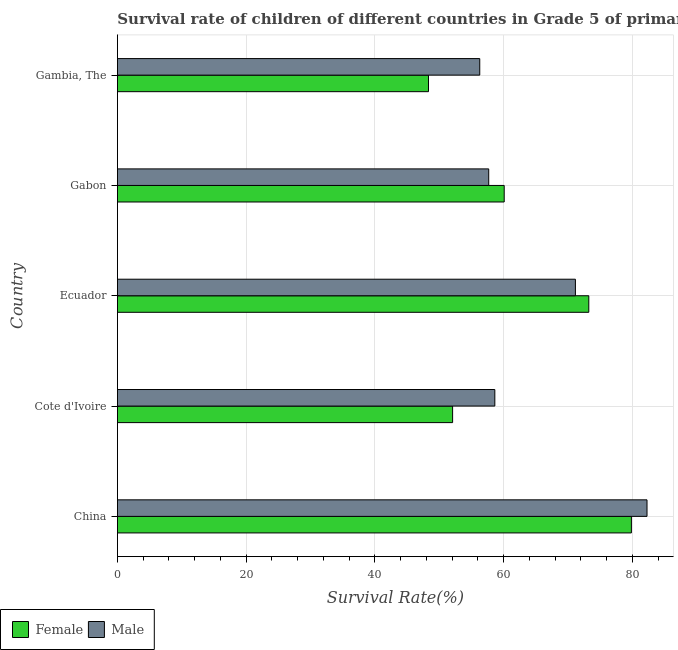How many different coloured bars are there?
Give a very brief answer. 2. How many bars are there on the 2nd tick from the bottom?
Provide a succinct answer. 2. What is the label of the 2nd group of bars from the top?
Ensure brevity in your answer.  Gabon. What is the survival rate of female students in primary education in Ecuador?
Your answer should be compact. 73.22. Across all countries, what is the maximum survival rate of male students in primary education?
Provide a succinct answer. 82.26. Across all countries, what is the minimum survival rate of female students in primary education?
Your answer should be very brief. 48.32. In which country was the survival rate of male students in primary education minimum?
Give a very brief answer. Gambia, The. What is the total survival rate of male students in primary education in the graph?
Your answer should be very brief. 325.99. What is the difference between the survival rate of male students in primary education in Cote d'Ivoire and that in Gabon?
Offer a very short reply. 0.95. What is the difference between the survival rate of female students in primary education in Ecuador and the survival rate of male students in primary education in Gabon?
Your answer should be very brief. 15.55. What is the average survival rate of male students in primary education per country?
Keep it short and to the point. 65.2. What is the difference between the survival rate of female students in primary education and survival rate of male students in primary education in China?
Offer a very short reply. -2.43. In how many countries, is the survival rate of male students in primary education greater than 20 %?
Give a very brief answer. 5. What is the ratio of the survival rate of male students in primary education in Cote d'Ivoire to that in Gambia, The?
Keep it short and to the point. 1.04. Is the difference between the survival rate of female students in primary education in Cote d'Ivoire and Gambia, The greater than the difference between the survival rate of male students in primary education in Cote d'Ivoire and Gambia, The?
Keep it short and to the point. Yes. What is the difference between the highest and the second highest survival rate of male students in primary education?
Your answer should be compact. 11.12. What is the difference between the highest and the lowest survival rate of male students in primary education?
Make the answer very short. 25.98. Is the sum of the survival rate of male students in primary education in China and Cote d'Ivoire greater than the maximum survival rate of female students in primary education across all countries?
Provide a succinct answer. Yes. What does the 2nd bar from the top in China represents?
Give a very brief answer. Female. What does the 2nd bar from the bottom in Gabon represents?
Keep it short and to the point. Male. How many bars are there?
Provide a short and direct response. 10. Are all the bars in the graph horizontal?
Offer a very short reply. Yes. What is the difference between two consecutive major ticks on the X-axis?
Your response must be concise. 20. Are the values on the major ticks of X-axis written in scientific E-notation?
Keep it short and to the point. No. Does the graph contain any zero values?
Your answer should be very brief. No. How many legend labels are there?
Your answer should be compact. 2. How are the legend labels stacked?
Your answer should be compact. Horizontal. What is the title of the graph?
Your answer should be compact. Survival rate of children of different countries in Grade 5 of primary education. Does "Canada" appear as one of the legend labels in the graph?
Ensure brevity in your answer.  No. What is the label or title of the X-axis?
Offer a terse response. Survival Rate(%). What is the Survival Rate(%) of Female in China?
Ensure brevity in your answer.  79.84. What is the Survival Rate(%) of Male in China?
Your answer should be very brief. 82.26. What is the Survival Rate(%) in Female in Cote d'Ivoire?
Offer a very short reply. 52.07. What is the Survival Rate(%) in Male in Cote d'Ivoire?
Make the answer very short. 58.63. What is the Survival Rate(%) of Female in Ecuador?
Your answer should be very brief. 73.22. What is the Survival Rate(%) of Male in Ecuador?
Ensure brevity in your answer.  71.14. What is the Survival Rate(%) of Female in Gabon?
Offer a terse response. 60.08. What is the Survival Rate(%) in Male in Gabon?
Your answer should be very brief. 57.68. What is the Survival Rate(%) of Female in Gambia, The?
Keep it short and to the point. 48.32. What is the Survival Rate(%) of Male in Gambia, The?
Offer a terse response. 56.28. Across all countries, what is the maximum Survival Rate(%) in Female?
Your answer should be very brief. 79.84. Across all countries, what is the maximum Survival Rate(%) in Male?
Offer a very short reply. 82.26. Across all countries, what is the minimum Survival Rate(%) of Female?
Provide a succinct answer. 48.32. Across all countries, what is the minimum Survival Rate(%) in Male?
Keep it short and to the point. 56.28. What is the total Survival Rate(%) in Female in the graph?
Your answer should be very brief. 313.53. What is the total Survival Rate(%) of Male in the graph?
Your response must be concise. 325.99. What is the difference between the Survival Rate(%) of Female in China and that in Cote d'Ivoire?
Provide a succinct answer. 27.77. What is the difference between the Survival Rate(%) of Male in China and that in Cote d'Ivoire?
Your response must be concise. 23.64. What is the difference between the Survival Rate(%) in Female in China and that in Ecuador?
Make the answer very short. 6.61. What is the difference between the Survival Rate(%) in Male in China and that in Ecuador?
Ensure brevity in your answer.  11.12. What is the difference between the Survival Rate(%) of Female in China and that in Gabon?
Provide a short and direct response. 19.76. What is the difference between the Survival Rate(%) of Male in China and that in Gabon?
Provide a short and direct response. 24.59. What is the difference between the Survival Rate(%) of Female in China and that in Gambia, The?
Ensure brevity in your answer.  31.52. What is the difference between the Survival Rate(%) of Male in China and that in Gambia, The?
Ensure brevity in your answer.  25.98. What is the difference between the Survival Rate(%) in Female in Cote d'Ivoire and that in Ecuador?
Give a very brief answer. -21.15. What is the difference between the Survival Rate(%) in Male in Cote d'Ivoire and that in Ecuador?
Make the answer very short. -12.52. What is the difference between the Survival Rate(%) in Female in Cote d'Ivoire and that in Gabon?
Offer a very short reply. -8.01. What is the difference between the Survival Rate(%) of Male in Cote d'Ivoire and that in Gabon?
Give a very brief answer. 0.95. What is the difference between the Survival Rate(%) in Female in Cote d'Ivoire and that in Gambia, The?
Offer a terse response. 3.75. What is the difference between the Survival Rate(%) in Male in Cote d'Ivoire and that in Gambia, The?
Ensure brevity in your answer.  2.34. What is the difference between the Survival Rate(%) of Female in Ecuador and that in Gabon?
Provide a short and direct response. 13.14. What is the difference between the Survival Rate(%) in Male in Ecuador and that in Gabon?
Make the answer very short. 13.47. What is the difference between the Survival Rate(%) of Female in Ecuador and that in Gambia, The?
Provide a short and direct response. 24.9. What is the difference between the Survival Rate(%) in Male in Ecuador and that in Gambia, The?
Your response must be concise. 14.86. What is the difference between the Survival Rate(%) in Female in Gabon and that in Gambia, The?
Your response must be concise. 11.76. What is the difference between the Survival Rate(%) of Male in Gabon and that in Gambia, The?
Give a very brief answer. 1.39. What is the difference between the Survival Rate(%) of Female in China and the Survival Rate(%) of Male in Cote d'Ivoire?
Your answer should be very brief. 21.21. What is the difference between the Survival Rate(%) of Female in China and the Survival Rate(%) of Male in Ecuador?
Offer a terse response. 8.7. What is the difference between the Survival Rate(%) in Female in China and the Survival Rate(%) in Male in Gabon?
Your answer should be very brief. 22.16. What is the difference between the Survival Rate(%) in Female in China and the Survival Rate(%) in Male in Gambia, The?
Keep it short and to the point. 23.55. What is the difference between the Survival Rate(%) of Female in Cote d'Ivoire and the Survival Rate(%) of Male in Ecuador?
Your answer should be very brief. -19.07. What is the difference between the Survival Rate(%) of Female in Cote d'Ivoire and the Survival Rate(%) of Male in Gabon?
Your answer should be very brief. -5.61. What is the difference between the Survival Rate(%) in Female in Cote d'Ivoire and the Survival Rate(%) in Male in Gambia, The?
Your response must be concise. -4.21. What is the difference between the Survival Rate(%) of Female in Ecuador and the Survival Rate(%) of Male in Gabon?
Give a very brief answer. 15.55. What is the difference between the Survival Rate(%) in Female in Ecuador and the Survival Rate(%) in Male in Gambia, The?
Your answer should be compact. 16.94. What is the difference between the Survival Rate(%) in Female in Gabon and the Survival Rate(%) in Male in Gambia, The?
Provide a succinct answer. 3.8. What is the average Survival Rate(%) of Female per country?
Provide a short and direct response. 62.71. What is the average Survival Rate(%) of Male per country?
Give a very brief answer. 65.2. What is the difference between the Survival Rate(%) of Female and Survival Rate(%) of Male in China?
Provide a short and direct response. -2.43. What is the difference between the Survival Rate(%) in Female and Survival Rate(%) in Male in Cote d'Ivoire?
Provide a succinct answer. -6.56. What is the difference between the Survival Rate(%) in Female and Survival Rate(%) in Male in Ecuador?
Provide a short and direct response. 2.08. What is the difference between the Survival Rate(%) in Female and Survival Rate(%) in Male in Gabon?
Give a very brief answer. 2.4. What is the difference between the Survival Rate(%) in Female and Survival Rate(%) in Male in Gambia, The?
Your response must be concise. -7.96. What is the ratio of the Survival Rate(%) in Female in China to that in Cote d'Ivoire?
Give a very brief answer. 1.53. What is the ratio of the Survival Rate(%) in Male in China to that in Cote d'Ivoire?
Your answer should be very brief. 1.4. What is the ratio of the Survival Rate(%) in Female in China to that in Ecuador?
Make the answer very short. 1.09. What is the ratio of the Survival Rate(%) of Male in China to that in Ecuador?
Your answer should be very brief. 1.16. What is the ratio of the Survival Rate(%) of Female in China to that in Gabon?
Offer a very short reply. 1.33. What is the ratio of the Survival Rate(%) of Male in China to that in Gabon?
Make the answer very short. 1.43. What is the ratio of the Survival Rate(%) of Female in China to that in Gambia, The?
Offer a terse response. 1.65. What is the ratio of the Survival Rate(%) in Male in China to that in Gambia, The?
Your answer should be compact. 1.46. What is the ratio of the Survival Rate(%) of Female in Cote d'Ivoire to that in Ecuador?
Offer a very short reply. 0.71. What is the ratio of the Survival Rate(%) of Male in Cote d'Ivoire to that in Ecuador?
Offer a very short reply. 0.82. What is the ratio of the Survival Rate(%) in Female in Cote d'Ivoire to that in Gabon?
Give a very brief answer. 0.87. What is the ratio of the Survival Rate(%) of Male in Cote d'Ivoire to that in Gabon?
Provide a short and direct response. 1.02. What is the ratio of the Survival Rate(%) of Female in Cote d'Ivoire to that in Gambia, The?
Provide a succinct answer. 1.08. What is the ratio of the Survival Rate(%) in Male in Cote d'Ivoire to that in Gambia, The?
Offer a terse response. 1.04. What is the ratio of the Survival Rate(%) in Female in Ecuador to that in Gabon?
Your answer should be compact. 1.22. What is the ratio of the Survival Rate(%) of Male in Ecuador to that in Gabon?
Provide a short and direct response. 1.23. What is the ratio of the Survival Rate(%) in Female in Ecuador to that in Gambia, The?
Ensure brevity in your answer.  1.52. What is the ratio of the Survival Rate(%) in Male in Ecuador to that in Gambia, The?
Make the answer very short. 1.26. What is the ratio of the Survival Rate(%) of Female in Gabon to that in Gambia, The?
Give a very brief answer. 1.24. What is the ratio of the Survival Rate(%) of Male in Gabon to that in Gambia, The?
Offer a terse response. 1.02. What is the difference between the highest and the second highest Survival Rate(%) in Female?
Your answer should be compact. 6.61. What is the difference between the highest and the second highest Survival Rate(%) of Male?
Provide a short and direct response. 11.12. What is the difference between the highest and the lowest Survival Rate(%) of Female?
Your answer should be very brief. 31.52. What is the difference between the highest and the lowest Survival Rate(%) of Male?
Your answer should be compact. 25.98. 